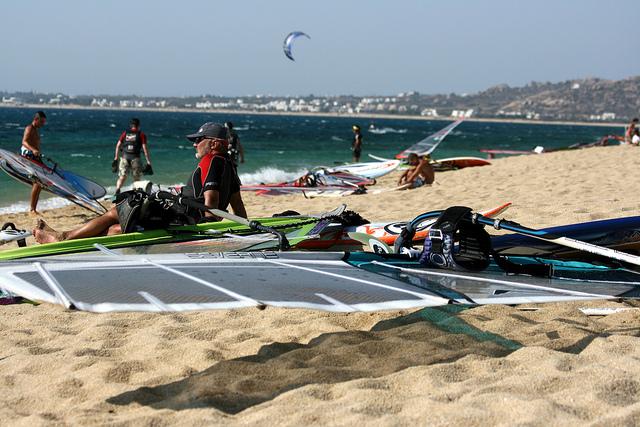Is the sand smooth?
Be succinct. No. Is this man retired?
Keep it brief. Yes. What is the man doing?
Concise answer only. Sitting on beach. 